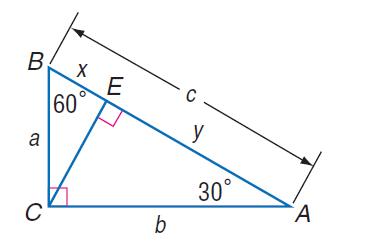Answer the mathemtical geometry problem and directly provide the correct option letter.
Question: If a = 10 \sqrt { 3 }, find C E.
Choices: A: 5 \sqrt 3 B: 10 C: 15 D: 10 \sqrt 3 C 